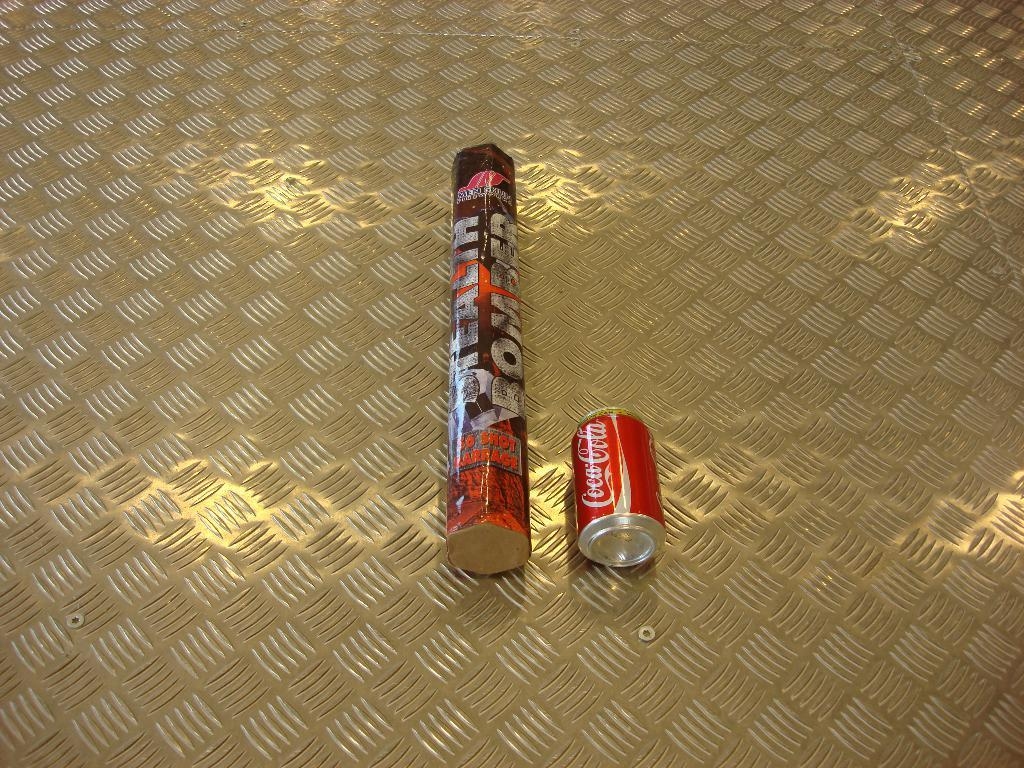What type of product is featured in the tin in the image? There is a Coca Cola tin in the image. What is located beside the Coca Cola tin in the image? There is an object beside the Coca Cola tin in the image. Where are the Coca Cola tin and the object beside it placed in the image? Both the Coca Cola tin and the object beside it are placed on the floor in the image. Can you tell me how many goats are visible in the image? There are no goats present in the image. What type of cannon is featured in the image? There is no cannon present in the image. 